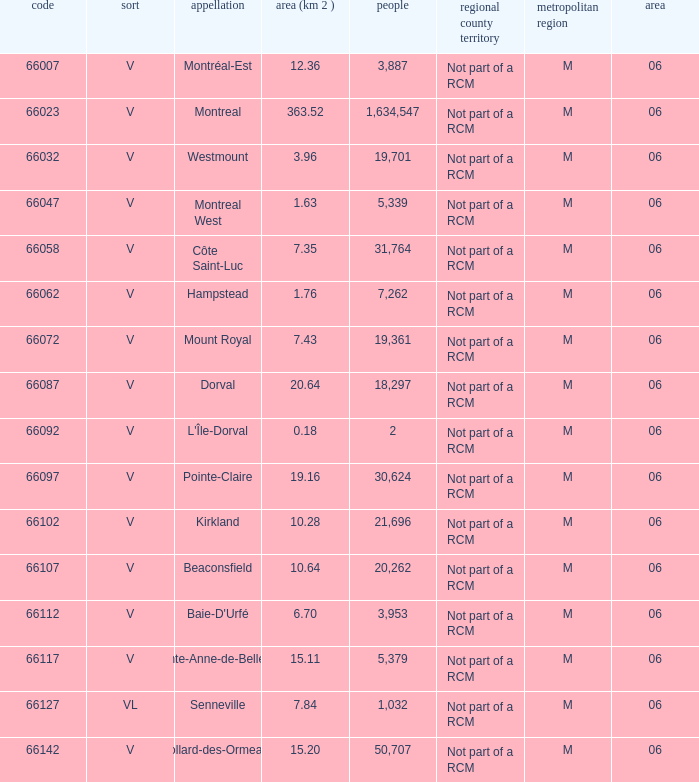Parse the table in full. {'header': ['code', 'sort', 'appellation', 'area (km 2 )', 'people', 'regional county territory', 'metropolitan region', 'area'], 'rows': [['66007', 'V', 'Montréal-Est', '12.36', '3,887', 'Not part of a RCM', 'M', '06'], ['66023', 'V', 'Montreal', '363.52', '1,634,547', 'Not part of a RCM', 'M', '06'], ['66032', 'V', 'Westmount', '3.96', '19,701', 'Not part of a RCM', 'M', '06'], ['66047', 'V', 'Montreal West', '1.63', '5,339', 'Not part of a RCM', 'M', '06'], ['66058', 'V', 'Côte Saint-Luc', '7.35', '31,764', 'Not part of a RCM', 'M', '06'], ['66062', 'V', 'Hampstead', '1.76', '7,262', 'Not part of a RCM', 'M', '06'], ['66072', 'V', 'Mount Royal', '7.43', '19,361', 'Not part of a RCM', 'M', '06'], ['66087', 'V', 'Dorval', '20.64', '18,297', 'Not part of a RCM', 'M', '06'], ['66092', 'V', "L'Île-Dorval", '0.18', '2', 'Not part of a RCM', 'M', '06'], ['66097', 'V', 'Pointe-Claire', '19.16', '30,624', 'Not part of a RCM', 'M', '06'], ['66102', 'V', 'Kirkland', '10.28', '21,696', 'Not part of a RCM', 'M', '06'], ['66107', 'V', 'Beaconsfield', '10.64', '20,262', 'Not part of a RCM', 'M', '06'], ['66112', 'V', "Baie-D'Urfé", '6.70', '3,953', 'Not part of a RCM', 'M', '06'], ['66117', 'V', 'Sainte-Anne-de-Bellevue', '15.11', '5,379', 'Not part of a RCM', 'M', '06'], ['66127', 'VL', 'Senneville', '7.84', '1,032', 'Not part of a RCM', 'M', '06'], ['66142', 'V', 'Dollard-des-Ormeaux', '15.20', '50,707', 'Not part of a RCM', 'M', '06']]} What is the largest region with a Code smaller than 66112, and a Name of l'île-dorval? 6.0. 